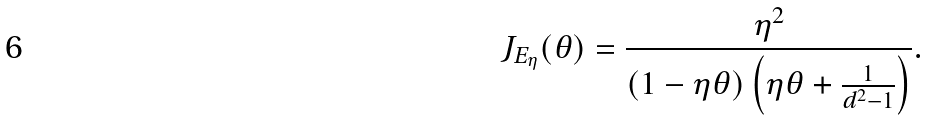<formula> <loc_0><loc_0><loc_500><loc_500>J _ { E _ { \eta } } ( \theta ) = \frac { \eta ^ { 2 } } { ( 1 - \eta \theta ) \left ( \eta \theta + \frac { 1 } { d ^ { 2 } - 1 } \right ) } .</formula> 